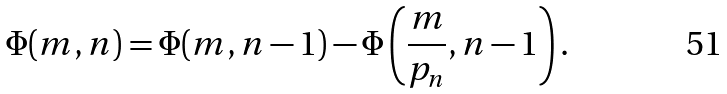<formula> <loc_0><loc_0><loc_500><loc_500>\Phi ( m , n ) = \Phi ( m , n - 1 ) - \Phi \left ( { \frac { m } { p _ { n } } } , n - 1 \right ) .</formula> 